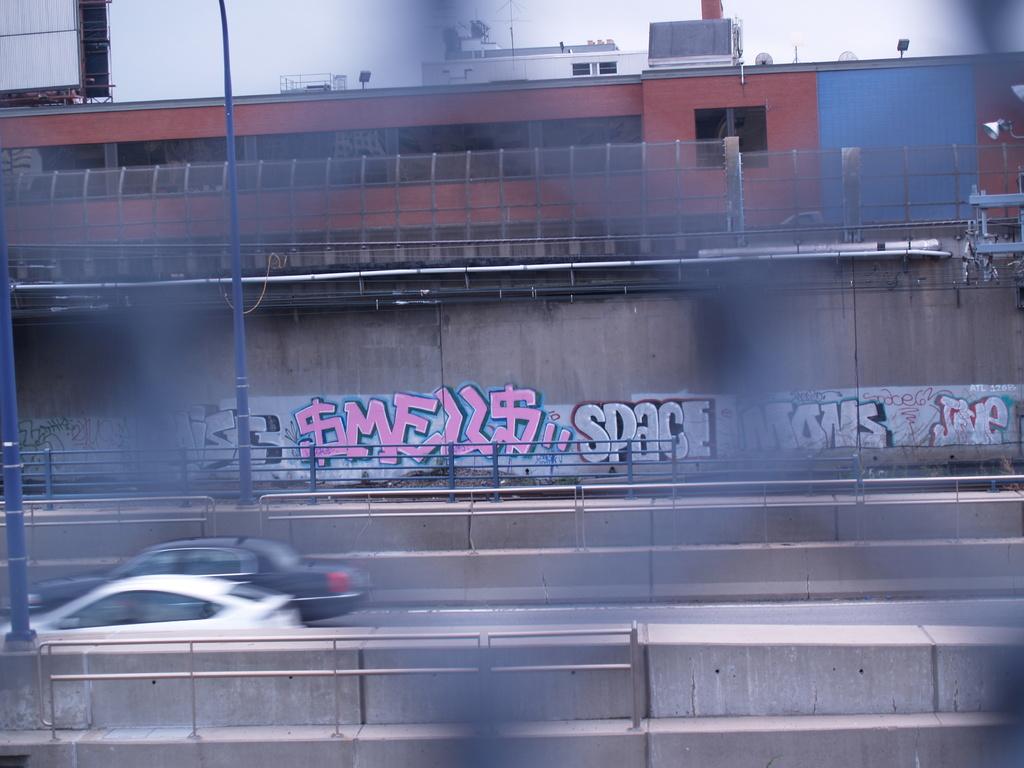What's written in pink graffiti?
Ensure brevity in your answer.  Smells. What does it say in green letters?
Offer a terse response. Space. 